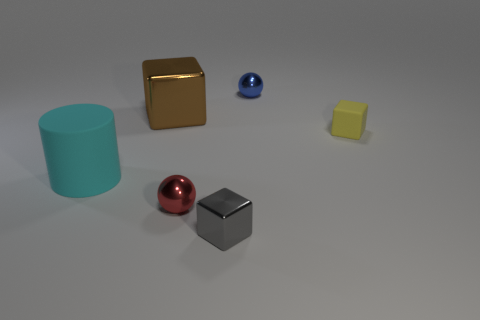Subtract all metal blocks. How many blocks are left? 1 Add 1 brown cubes. How many objects exist? 7 Subtract all brown blocks. How many blocks are left? 2 Subtract all spheres. How many objects are left? 4 Add 4 metal cubes. How many metal cubes are left? 6 Add 4 red matte balls. How many red matte balls exist? 4 Subtract 1 cyan cylinders. How many objects are left? 5 Subtract all yellow cubes. Subtract all brown cylinders. How many cubes are left? 2 Subtract all yellow matte objects. Subtract all yellow things. How many objects are left? 4 